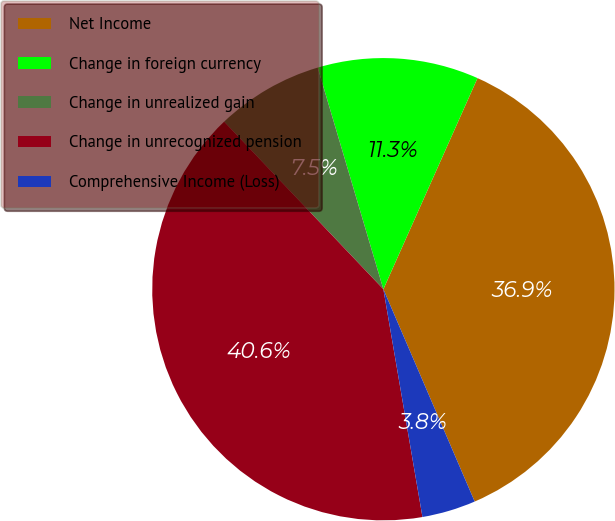Convert chart. <chart><loc_0><loc_0><loc_500><loc_500><pie_chart><fcel>Net Income<fcel>Change in foreign currency<fcel>Change in unrealized gain<fcel>Change in unrecognized pension<fcel>Comprehensive Income (Loss)<nl><fcel>36.86%<fcel>11.26%<fcel>7.51%<fcel>40.61%<fcel>3.76%<nl></chart> 